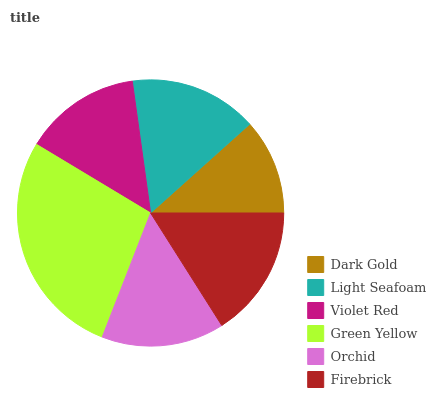Is Dark Gold the minimum?
Answer yes or no. Yes. Is Green Yellow the maximum?
Answer yes or no. Yes. Is Light Seafoam the minimum?
Answer yes or no. No. Is Light Seafoam the maximum?
Answer yes or no. No. Is Light Seafoam greater than Dark Gold?
Answer yes or no. Yes. Is Dark Gold less than Light Seafoam?
Answer yes or no. Yes. Is Dark Gold greater than Light Seafoam?
Answer yes or no. No. Is Light Seafoam less than Dark Gold?
Answer yes or no. No. Is Light Seafoam the high median?
Answer yes or no. Yes. Is Orchid the low median?
Answer yes or no. Yes. Is Firebrick the high median?
Answer yes or no. No. Is Violet Red the low median?
Answer yes or no. No. 